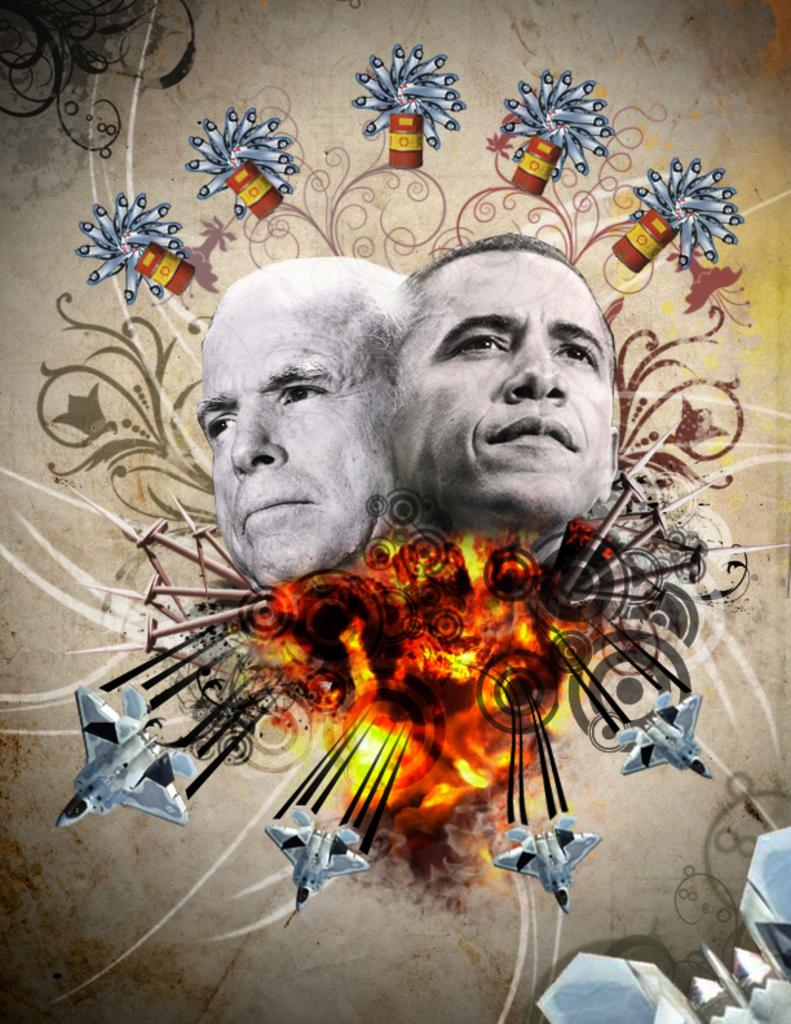What is the main feature of the image? There is a banner in the image. What types of images are on the banner? The banner contains images of jet planes, fire, and two people's faces. What is the price of the jet plane depicted on the banner? The image on the banner is not a real jet plane, so there is no price associated with it. 